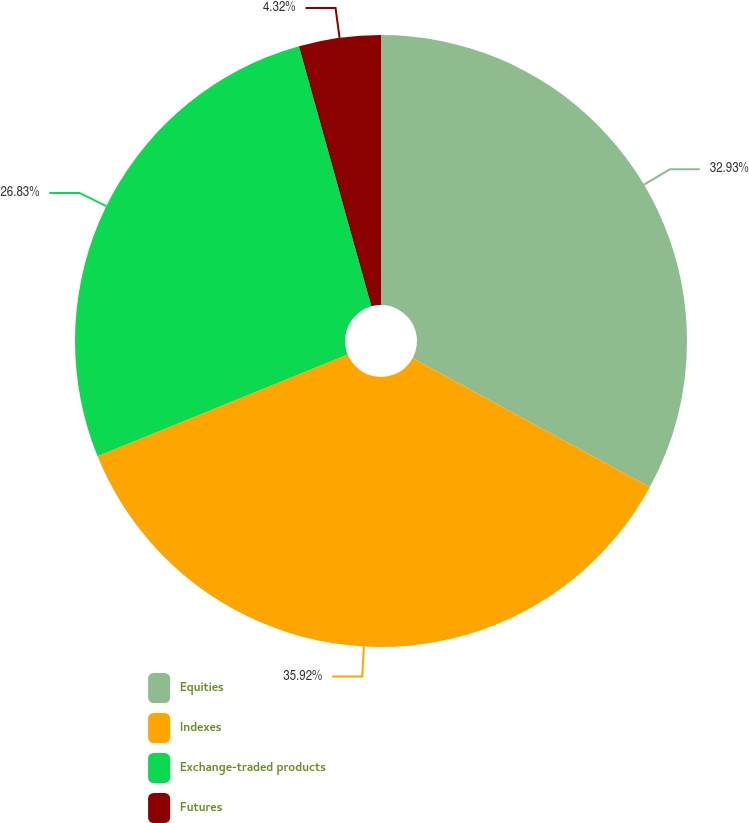Convert chart. <chart><loc_0><loc_0><loc_500><loc_500><pie_chart><fcel>Equities<fcel>Indexes<fcel>Exchange-traded products<fcel>Futures<nl><fcel>32.93%<fcel>35.92%<fcel>26.83%<fcel>4.32%<nl></chart> 